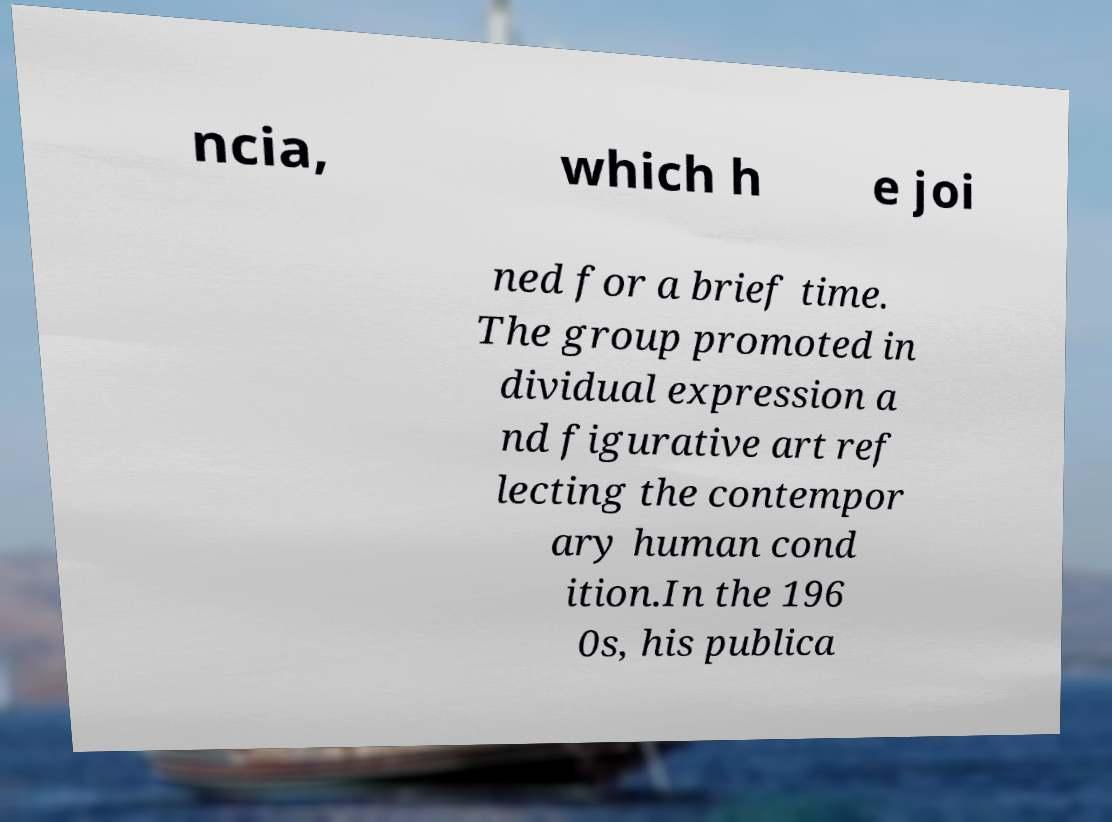Could you assist in decoding the text presented in this image and type it out clearly? ncia, which h e joi ned for a brief time. The group promoted in dividual expression a nd figurative art ref lecting the contempor ary human cond ition.In the 196 0s, his publica 